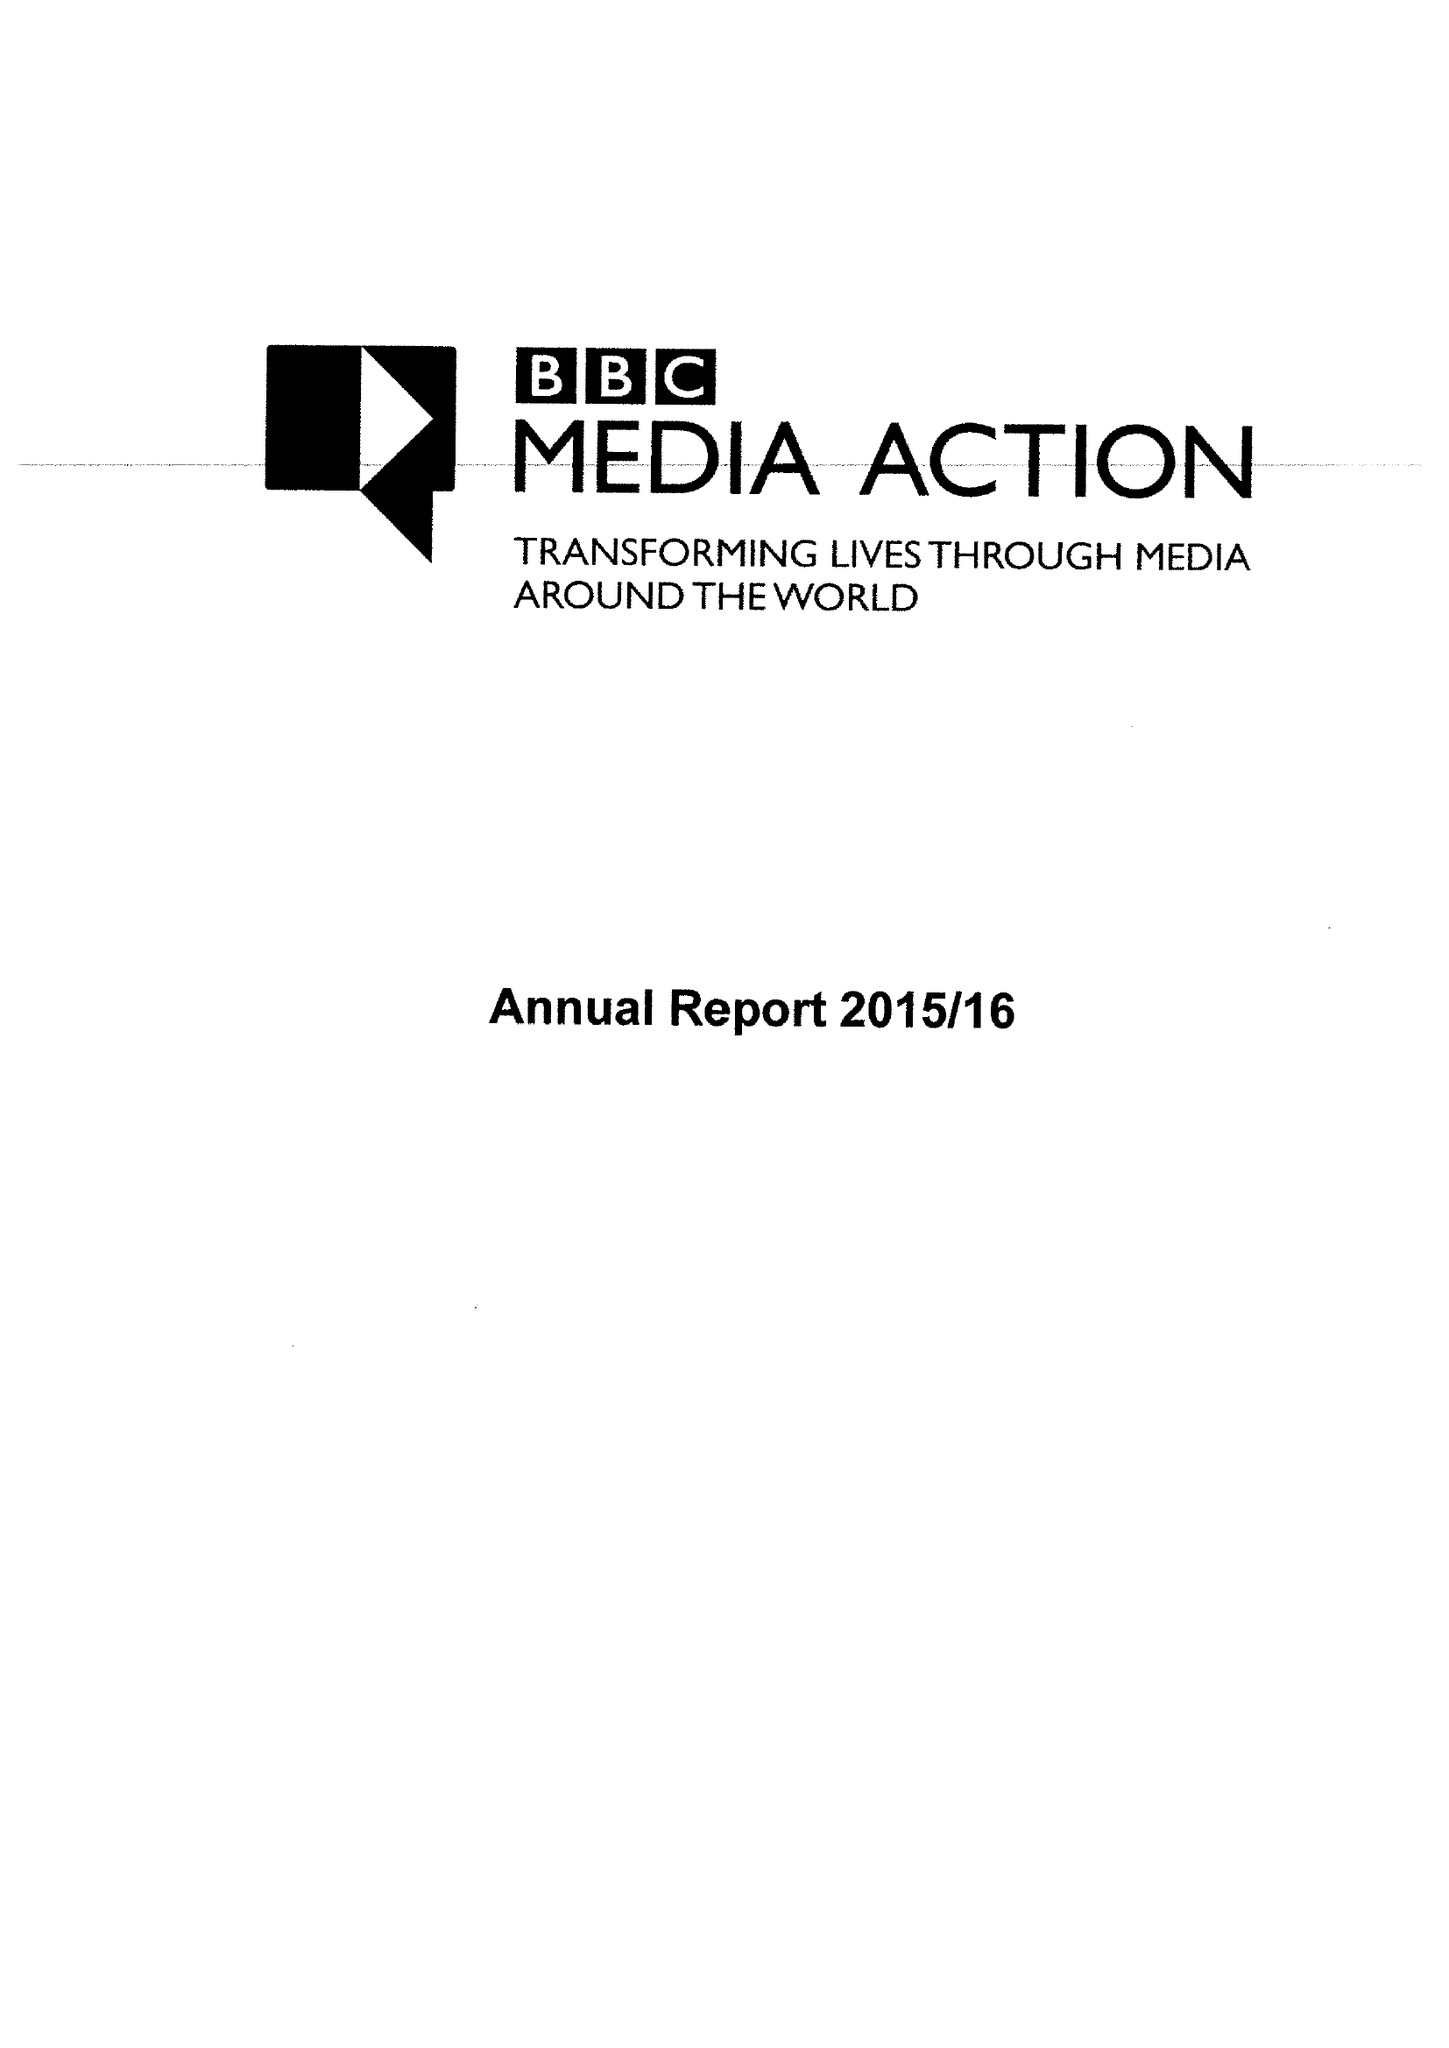What is the value for the address__post_town?
Answer the question using a single word or phrase. LONDON 